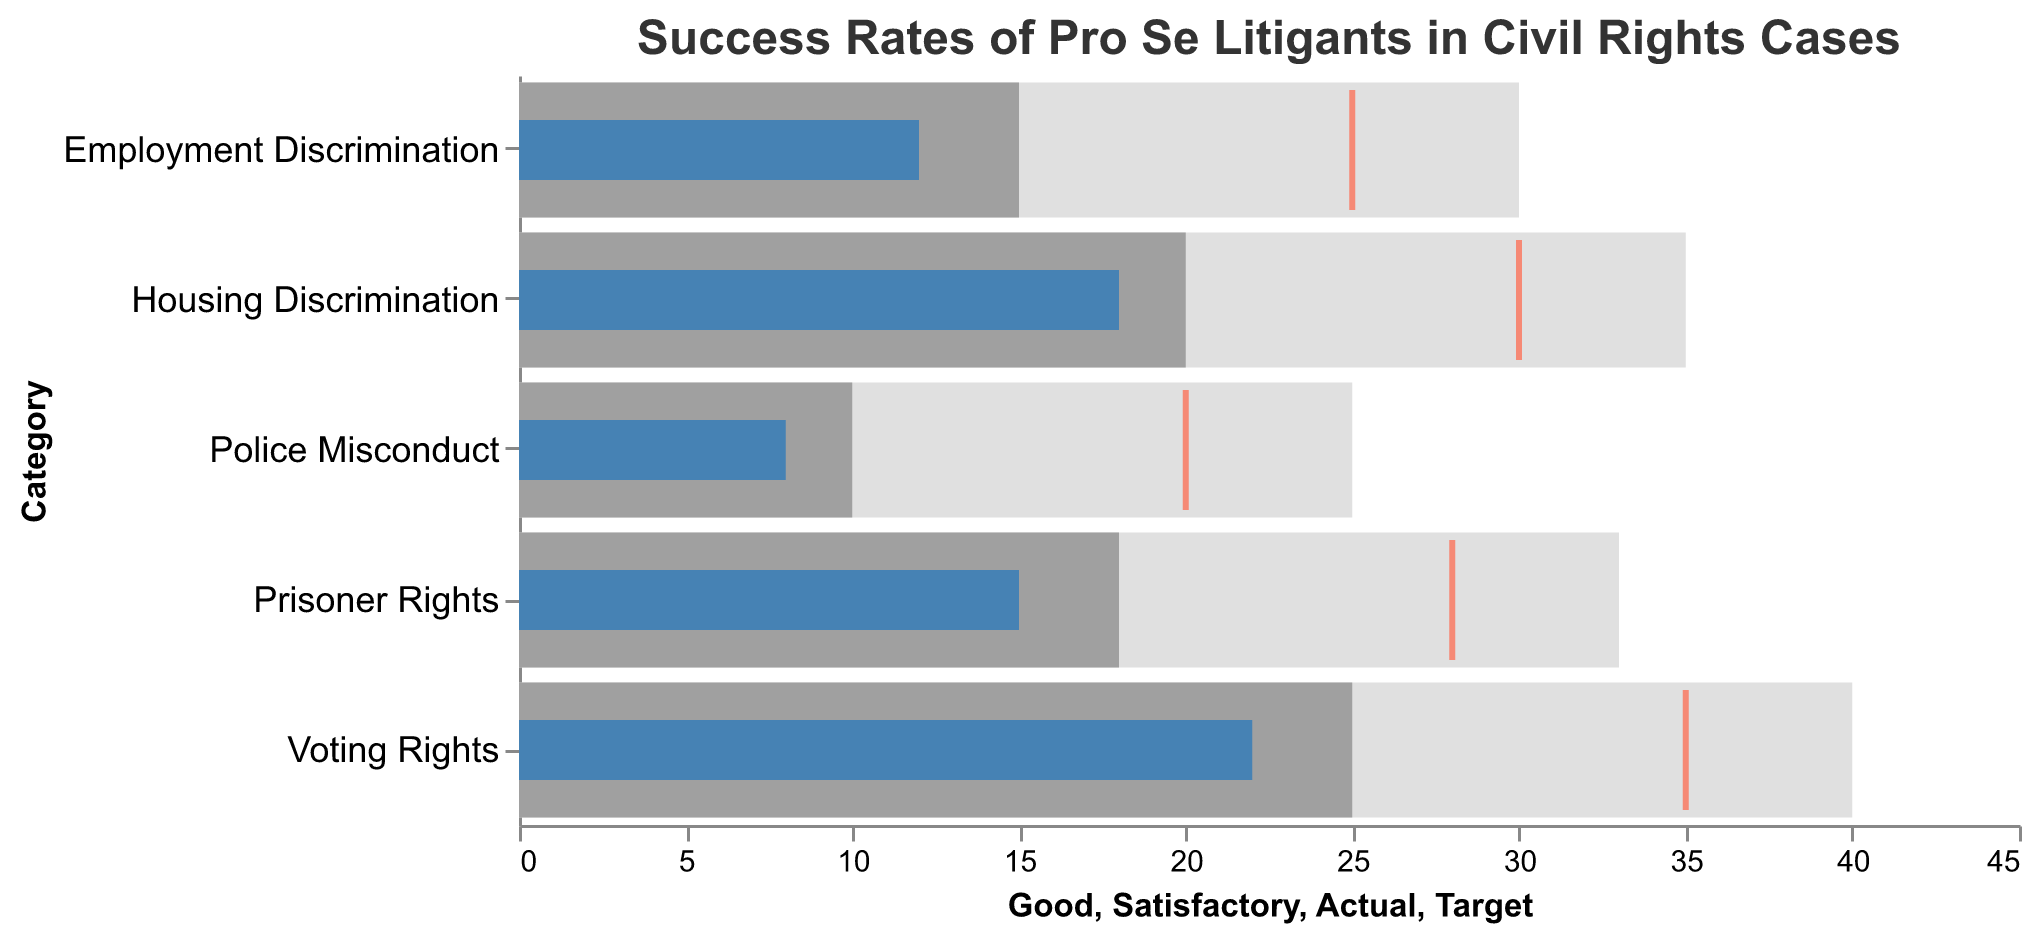What is the title of the chart? The chart displays a title at the top, indicating the subject matter. The title is "Success Rates of Pro Se Litigants in Civil Rights Cases".
Answer: Success Rates of Pro Se Litigants in Civil Rights Cases What color represents the actual success rate? The actual success rate is shown using a specific color, in this case, blue. This is visually distinguishable from the other elements on the chart.
Answer: Blue Which category has the highest target success rate? By examining the positions of the red tick marks representing the target success rates, we can see that the Voting Rights category has the highest target at 35.
Answer: Voting Rights What is the actual success rate for Housing Discrimination cases? The actual success rate for Housing Discrimination cases is represented by the blue bar for this category, which reaches up to 18 on the quantitative axis.
Answer: 18 How much higher is the target success rate than the actual success rate in Employment Discrimination cases? By comparing the target and actual success rates for Employment Discrimination, we see the target is 25 and the actual is 12. The difference is 25 - 12.
Answer: 13 What range is considered "Good" for Prisoner Rights cases? The range for "Good" is shown by the end of the light grey bar, which for Prisoner Rights extends from 0 to 33.
Answer: 0 - 33 For which categories do the actual success rates fall into the "Poor" range? The "Poor" range is from 0 upwards but not reaching the "Satisfactory" range. Comparing the actual success rates, Employment Discrimination and Police Misconduct fall into this range.
Answer: Employment Discrimination, Police Misconduct Which category shows the smallest gap between the actual and target success rates? Calculating the difference for each category, Voting Rights has the smallest gap, which is 35 - 22 = 13. That’s equal to Employment Discrimination, also at 13, so both have the smallest gap.
Answer: Voting Rights, Employment Discrimination What is the median actual success rate across all categories? Listing the actual success rates in ascending order: 8, 12, 15, 18, 22, the middle value (median) is 15.
Answer: 15 In which category is the “Satisfactory” range highest? The "Satisfactory" range is the darker grey segment, and for Voting Rights, it ends at 25, which is highest among all.
Answer: Voting Rights 